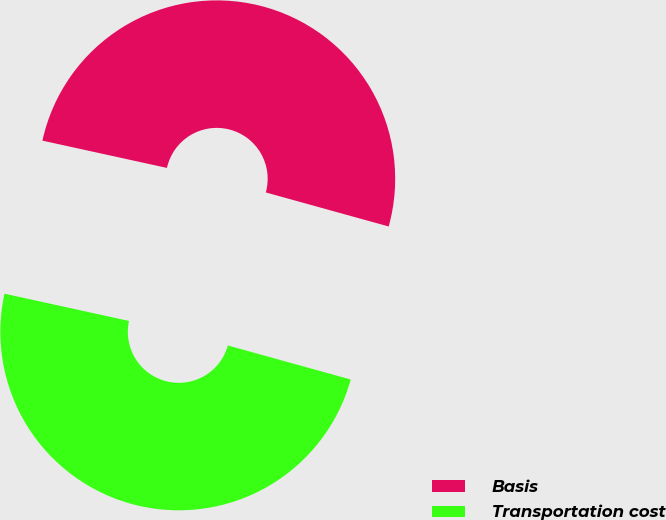Convert chart to OTSL. <chart><loc_0><loc_0><loc_500><loc_500><pie_chart><fcel>Basis<fcel>Transportation cost<nl><fcel>50.87%<fcel>49.13%<nl></chart> 